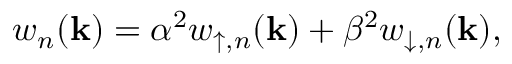Convert formula to latex. <formula><loc_0><loc_0><loc_500><loc_500>w _ { n } ( k ) = \alpha ^ { 2 } w _ { \uparrow , n } ( k ) + \beta ^ { 2 } w _ { \downarrow , n } ( k ) ,</formula> 